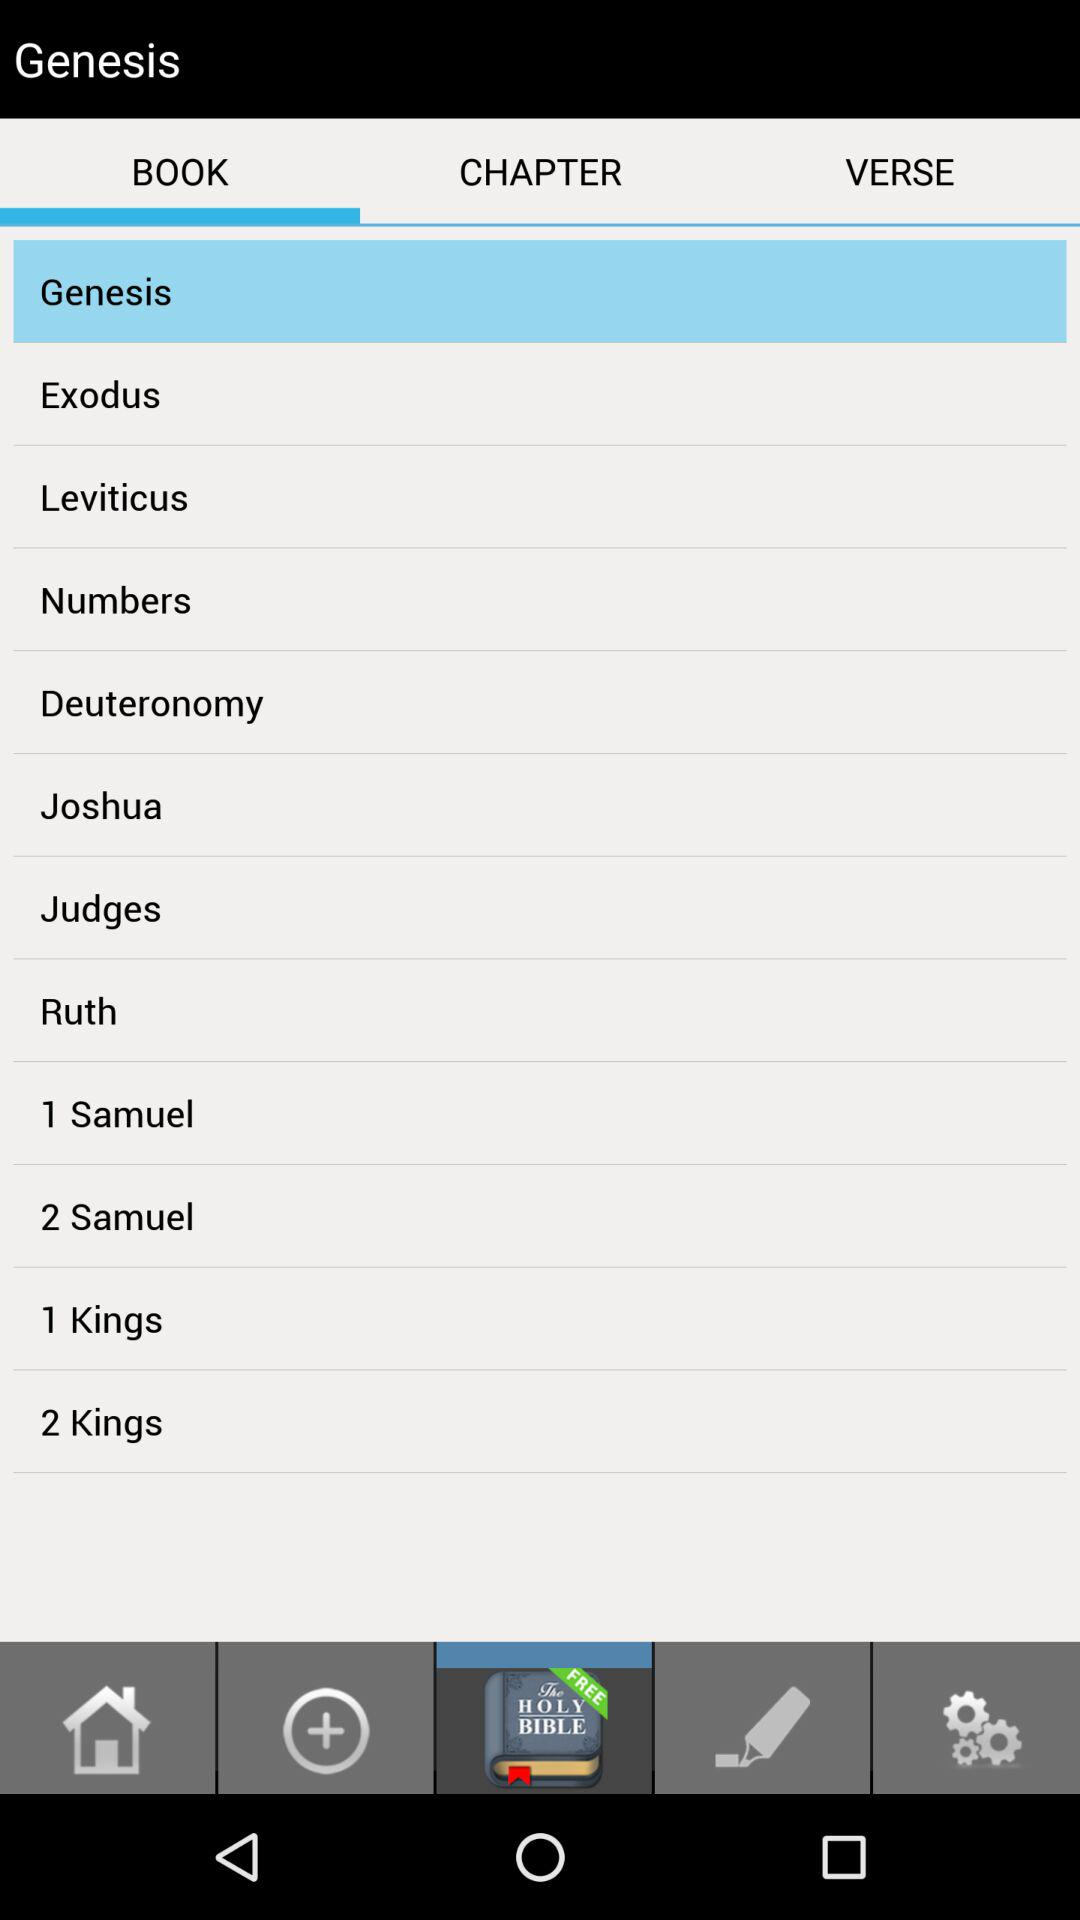Which tab has been selected? The selected tab is "BOOK". 